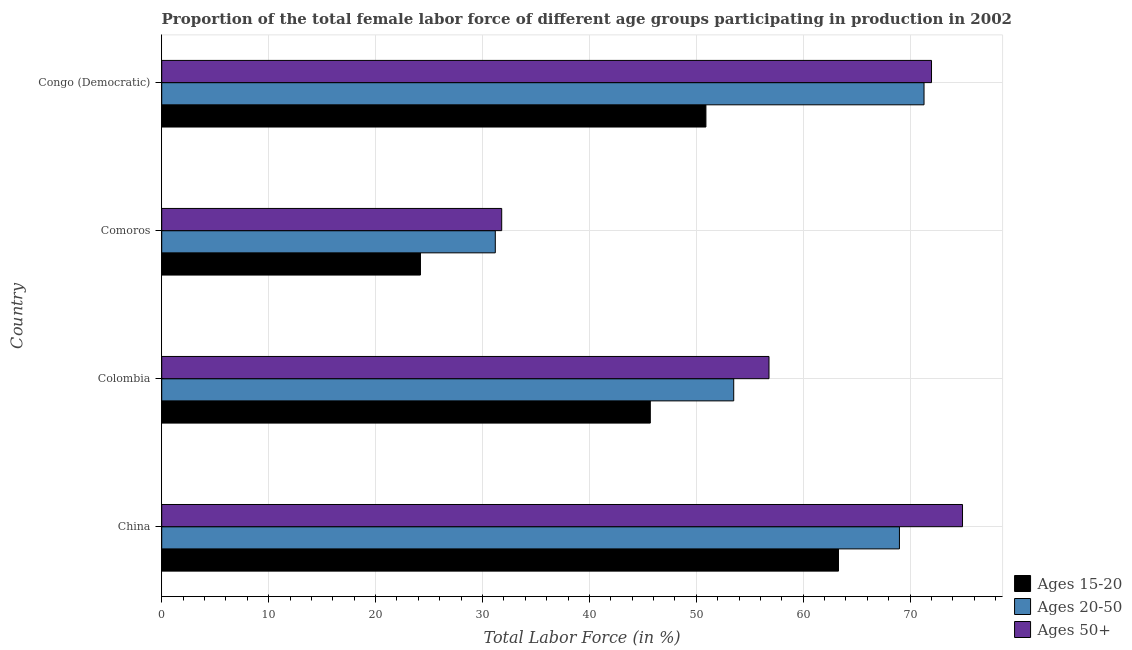Are the number of bars per tick equal to the number of legend labels?
Keep it short and to the point. Yes. Are the number of bars on each tick of the Y-axis equal?
Your response must be concise. Yes. How many bars are there on the 2nd tick from the top?
Provide a short and direct response. 3. How many bars are there on the 4th tick from the bottom?
Provide a succinct answer. 3. What is the percentage of female labor force within the age group 15-20 in Colombia?
Your response must be concise. 45.7. Across all countries, what is the maximum percentage of female labor force within the age group 15-20?
Keep it short and to the point. 63.3. Across all countries, what is the minimum percentage of female labor force within the age group 20-50?
Provide a succinct answer. 31.2. In which country was the percentage of female labor force above age 50 minimum?
Give a very brief answer. Comoros. What is the total percentage of female labor force above age 50 in the graph?
Your answer should be compact. 235.5. What is the difference between the percentage of female labor force within the age group 15-20 in China and the percentage of female labor force above age 50 in Colombia?
Provide a succinct answer. 6.5. What is the average percentage of female labor force above age 50 per country?
Make the answer very short. 58.88. What is the difference between the percentage of female labor force within the age group 20-50 and percentage of female labor force above age 50 in Comoros?
Your answer should be compact. -0.6. In how many countries, is the percentage of female labor force within the age group 20-50 greater than 64 %?
Offer a terse response. 2. What is the ratio of the percentage of female labor force within the age group 20-50 in Colombia to that in Comoros?
Provide a succinct answer. 1.72. Is the percentage of female labor force within the age group 15-20 in Colombia less than that in Comoros?
Give a very brief answer. No. Is the difference between the percentage of female labor force within the age group 15-20 in China and Colombia greater than the difference between the percentage of female labor force within the age group 20-50 in China and Colombia?
Your response must be concise. Yes. What is the difference between the highest and the second highest percentage of female labor force within the age group 15-20?
Make the answer very short. 12.4. What is the difference between the highest and the lowest percentage of female labor force above age 50?
Your response must be concise. 43.1. Is the sum of the percentage of female labor force within the age group 20-50 in Colombia and Comoros greater than the maximum percentage of female labor force above age 50 across all countries?
Provide a short and direct response. Yes. What does the 2nd bar from the top in China represents?
Give a very brief answer. Ages 20-50. What does the 3rd bar from the bottom in Colombia represents?
Give a very brief answer. Ages 50+. Is it the case that in every country, the sum of the percentage of female labor force within the age group 15-20 and percentage of female labor force within the age group 20-50 is greater than the percentage of female labor force above age 50?
Offer a very short reply. Yes. What is the difference between two consecutive major ticks on the X-axis?
Offer a very short reply. 10. Does the graph contain grids?
Keep it short and to the point. Yes. Where does the legend appear in the graph?
Make the answer very short. Bottom right. How many legend labels are there?
Make the answer very short. 3. How are the legend labels stacked?
Provide a short and direct response. Vertical. What is the title of the graph?
Ensure brevity in your answer.  Proportion of the total female labor force of different age groups participating in production in 2002. Does "Wage workers" appear as one of the legend labels in the graph?
Ensure brevity in your answer.  No. What is the label or title of the Y-axis?
Make the answer very short. Country. What is the Total Labor Force (in %) of Ages 15-20 in China?
Your answer should be compact. 63.3. What is the Total Labor Force (in %) in Ages 50+ in China?
Give a very brief answer. 74.9. What is the Total Labor Force (in %) of Ages 15-20 in Colombia?
Your answer should be compact. 45.7. What is the Total Labor Force (in %) in Ages 20-50 in Colombia?
Keep it short and to the point. 53.5. What is the Total Labor Force (in %) in Ages 50+ in Colombia?
Give a very brief answer. 56.8. What is the Total Labor Force (in %) in Ages 15-20 in Comoros?
Ensure brevity in your answer.  24.2. What is the Total Labor Force (in %) of Ages 20-50 in Comoros?
Provide a succinct answer. 31.2. What is the Total Labor Force (in %) of Ages 50+ in Comoros?
Provide a succinct answer. 31.8. What is the Total Labor Force (in %) in Ages 15-20 in Congo (Democratic)?
Offer a terse response. 50.9. What is the Total Labor Force (in %) in Ages 20-50 in Congo (Democratic)?
Provide a succinct answer. 71.3. What is the Total Labor Force (in %) of Ages 50+ in Congo (Democratic)?
Make the answer very short. 72. Across all countries, what is the maximum Total Labor Force (in %) of Ages 15-20?
Offer a very short reply. 63.3. Across all countries, what is the maximum Total Labor Force (in %) in Ages 20-50?
Offer a terse response. 71.3. Across all countries, what is the maximum Total Labor Force (in %) in Ages 50+?
Offer a very short reply. 74.9. Across all countries, what is the minimum Total Labor Force (in %) of Ages 15-20?
Your answer should be compact. 24.2. Across all countries, what is the minimum Total Labor Force (in %) of Ages 20-50?
Ensure brevity in your answer.  31.2. Across all countries, what is the minimum Total Labor Force (in %) of Ages 50+?
Ensure brevity in your answer.  31.8. What is the total Total Labor Force (in %) in Ages 15-20 in the graph?
Offer a terse response. 184.1. What is the total Total Labor Force (in %) in Ages 20-50 in the graph?
Provide a succinct answer. 225. What is the total Total Labor Force (in %) of Ages 50+ in the graph?
Your response must be concise. 235.5. What is the difference between the Total Labor Force (in %) of Ages 15-20 in China and that in Colombia?
Provide a succinct answer. 17.6. What is the difference between the Total Labor Force (in %) in Ages 15-20 in China and that in Comoros?
Give a very brief answer. 39.1. What is the difference between the Total Labor Force (in %) in Ages 20-50 in China and that in Comoros?
Offer a terse response. 37.8. What is the difference between the Total Labor Force (in %) in Ages 50+ in China and that in Comoros?
Offer a terse response. 43.1. What is the difference between the Total Labor Force (in %) in Ages 20-50 in China and that in Congo (Democratic)?
Your response must be concise. -2.3. What is the difference between the Total Labor Force (in %) in Ages 20-50 in Colombia and that in Comoros?
Provide a short and direct response. 22.3. What is the difference between the Total Labor Force (in %) of Ages 20-50 in Colombia and that in Congo (Democratic)?
Provide a short and direct response. -17.8. What is the difference between the Total Labor Force (in %) of Ages 50+ in Colombia and that in Congo (Democratic)?
Offer a terse response. -15.2. What is the difference between the Total Labor Force (in %) of Ages 15-20 in Comoros and that in Congo (Democratic)?
Your answer should be very brief. -26.7. What is the difference between the Total Labor Force (in %) in Ages 20-50 in Comoros and that in Congo (Democratic)?
Give a very brief answer. -40.1. What is the difference between the Total Labor Force (in %) of Ages 50+ in Comoros and that in Congo (Democratic)?
Ensure brevity in your answer.  -40.2. What is the difference between the Total Labor Force (in %) in Ages 15-20 in China and the Total Labor Force (in %) in Ages 50+ in Colombia?
Provide a short and direct response. 6.5. What is the difference between the Total Labor Force (in %) in Ages 15-20 in China and the Total Labor Force (in %) in Ages 20-50 in Comoros?
Provide a succinct answer. 32.1. What is the difference between the Total Labor Force (in %) in Ages 15-20 in China and the Total Labor Force (in %) in Ages 50+ in Comoros?
Keep it short and to the point. 31.5. What is the difference between the Total Labor Force (in %) in Ages 20-50 in China and the Total Labor Force (in %) in Ages 50+ in Comoros?
Provide a short and direct response. 37.2. What is the difference between the Total Labor Force (in %) in Ages 15-20 in China and the Total Labor Force (in %) in Ages 20-50 in Congo (Democratic)?
Ensure brevity in your answer.  -8. What is the difference between the Total Labor Force (in %) of Ages 15-20 in Colombia and the Total Labor Force (in %) of Ages 20-50 in Comoros?
Give a very brief answer. 14.5. What is the difference between the Total Labor Force (in %) of Ages 20-50 in Colombia and the Total Labor Force (in %) of Ages 50+ in Comoros?
Your answer should be very brief. 21.7. What is the difference between the Total Labor Force (in %) of Ages 15-20 in Colombia and the Total Labor Force (in %) of Ages 20-50 in Congo (Democratic)?
Give a very brief answer. -25.6. What is the difference between the Total Labor Force (in %) in Ages 15-20 in Colombia and the Total Labor Force (in %) in Ages 50+ in Congo (Democratic)?
Provide a succinct answer. -26.3. What is the difference between the Total Labor Force (in %) in Ages 20-50 in Colombia and the Total Labor Force (in %) in Ages 50+ in Congo (Democratic)?
Your response must be concise. -18.5. What is the difference between the Total Labor Force (in %) in Ages 15-20 in Comoros and the Total Labor Force (in %) in Ages 20-50 in Congo (Democratic)?
Offer a terse response. -47.1. What is the difference between the Total Labor Force (in %) of Ages 15-20 in Comoros and the Total Labor Force (in %) of Ages 50+ in Congo (Democratic)?
Your answer should be compact. -47.8. What is the difference between the Total Labor Force (in %) of Ages 20-50 in Comoros and the Total Labor Force (in %) of Ages 50+ in Congo (Democratic)?
Provide a succinct answer. -40.8. What is the average Total Labor Force (in %) in Ages 15-20 per country?
Provide a short and direct response. 46.02. What is the average Total Labor Force (in %) of Ages 20-50 per country?
Offer a terse response. 56.25. What is the average Total Labor Force (in %) in Ages 50+ per country?
Keep it short and to the point. 58.88. What is the difference between the Total Labor Force (in %) in Ages 15-20 and Total Labor Force (in %) in Ages 20-50 in China?
Offer a terse response. -5.7. What is the difference between the Total Labor Force (in %) in Ages 15-20 and Total Labor Force (in %) in Ages 50+ in China?
Keep it short and to the point. -11.6. What is the difference between the Total Labor Force (in %) of Ages 15-20 and Total Labor Force (in %) of Ages 20-50 in Colombia?
Your answer should be very brief. -7.8. What is the difference between the Total Labor Force (in %) in Ages 15-20 and Total Labor Force (in %) in Ages 50+ in Comoros?
Your answer should be very brief. -7.6. What is the difference between the Total Labor Force (in %) of Ages 15-20 and Total Labor Force (in %) of Ages 20-50 in Congo (Democratic)?
Your response must be concise. -20.4. What is the difference between the Total Labor Force (in %) in Ages 15-20 and Total Labor Force (in %) in Ages 50+ in Congo (Democratic)?
Offer a terse response. -21.1. What is the ratio of the Total Labor Force (in %) in Ages 15-20 in China to that in Colombia?
Your answer should be very brief. 1.39. What is the ratio of the Total Labor Force (in %) in Ages 20-50 in China to that in Colombia?
Give a very brief answer. 1.29. What is the ratio of the Total Labor Force (in %) in Ages 50+ in China to that in Colombia?
Offer a very short reply. 1.32. What is the ratio of the Total Labor Force (in %) of Ages 15-20 in China to that in Comoros?
Your answer should be very brief. 2.62. What is the ratio of the Total Labor Force (in %) in Ages 20-50 in China to that in Comoros?
Your answer should be compact. 2.21. What is the ratio of the Total Labor Force (in %) in Ages 50+ in China to that in Comoros?
Offer a very short reply. 2.36. What is the ratio of the Total Labor Force (in %) in Ages 15-20 in China to that in Congo (Democratic)?
Your answer should be compact. 1.24. What is the ratio of the Total Labor Force (in %) of Ages 20-50 in China to that in Congo (Democratic)?
Ensure brevity in your answer.  0.97. What is the ratio of the Total Labor Force (in %) of Ages 50+ in China to that in Congo (Democratic)?
Your response must be concise. 1.04. What is the ratio of the Total Labor Force (in %) in Ages 15-20 in Colombia to that in Comoros?
Offer a very short reply. 1.89. What is the ratio of the Total Labor Force (in %) in Ages 20-50 in Colombia to that in Comoros?
Give a very brief answer. 1.71. What is the ratio of the Total Labor Force (in %) of Ages 50+ in Colombia to that in Comoros?
Your answer should be compact. 1.79. What is the ratio of the Total Labor Force (in %) in Ages 15-20 in Colombia to that in Congo (Democratic)?
Your response must be concise. 0.9. What is the ratio of the Total Labor Force (in %) of Ages 20-50 in Colombia to that in Congo (Democratic)?
Make the answer very short. 0.75. What is the ratio of the Total Labor Force (in %) in Ages 50+ in Colombia to that in Congo (Democratic)?
Your answer should be compact. 0.79. What is the ratio of the Total Labor Force (in %) of Ages 15-20 in Comoros to that in Congo (Democratic)?
Offer a very short reply. 0.48. What is the ratio of the Total Labor Force (in %) in Ages 20-50 in Comoros to that in Congo (Democratic)?
Make the answer very short. 0.44. What is the ratio of the Total Labor Force (in %) of Ages 50+ in Comoros to that in Congo (Democratic)?
Your answer should be very brief. 0.44. What is the difference between the highest and the second highest Total Labor Force (in %) in Ages 20-50?
Your answer should be very brief. 2.3. What is the difference between the highest and the lowest Total Labor Force (in %) in Ages 15-20?
Offer a terse response. 39.1. What is the difference between the highest and the lowest Total Labor Force (in %) of Ages 20-50?
Provide a succinct answer. 40.1. What is the difference between the highest and the lowest Total Labor Force (in %) of Ages 50+?
Provide a succinct answer. 43.1. 